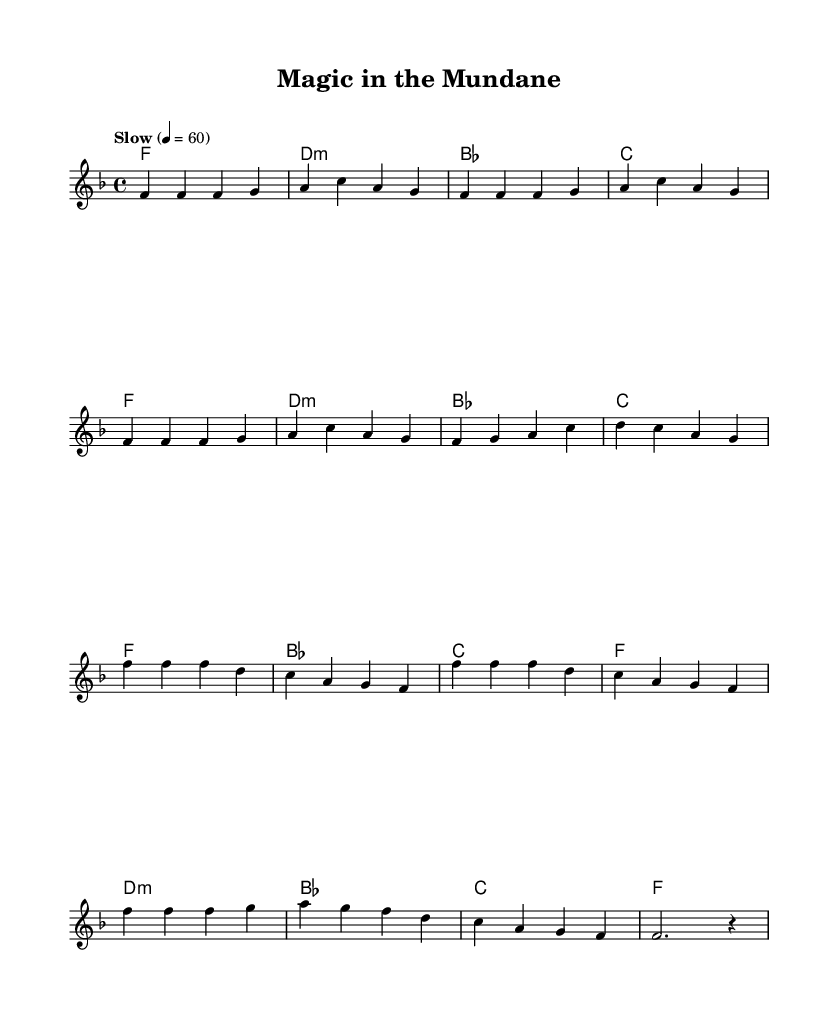What is the key signature of this music? The key signature is F major, which has one flat (B flat).
Answer: F major What is the time signature of this music? The time signature is 4/4, meaning there are four beats in each measure, and each quarter note gets one beat.
Answer: 4/4 What is the tempo marking for this piece? The tempo marking indicates a slow tempo of 60 beats per minute, which is specified by the notation "Slow" followed by the metronome marking.
Answer: Slow How many measures are in the verse section? The verse section consists of 8 measures, as counted in the lyrics provided. Each group of notes separated by vertical lines represents a measure.
Answer: 8 What is the harmonic progression of the chorus? The harmonic progression of the chorus follows the chords F, B flat, C, and F, followed by D minor, B flat, C, and F, as denoted in the sheet music.
Answer: F, B flat, C, F, D minor, B flat, C, F Which chord is played in the first measure of the verse? The first measure of the verse contains the F major chord, as indicated by the chord symbol written beneath the notes.
Answer: F What is the rhythmic value of the last note in the melody? The last note in the melody is a half note, indicated by the notation that shows it is held for two beats before the subsequent rest.
Answer: Half note 